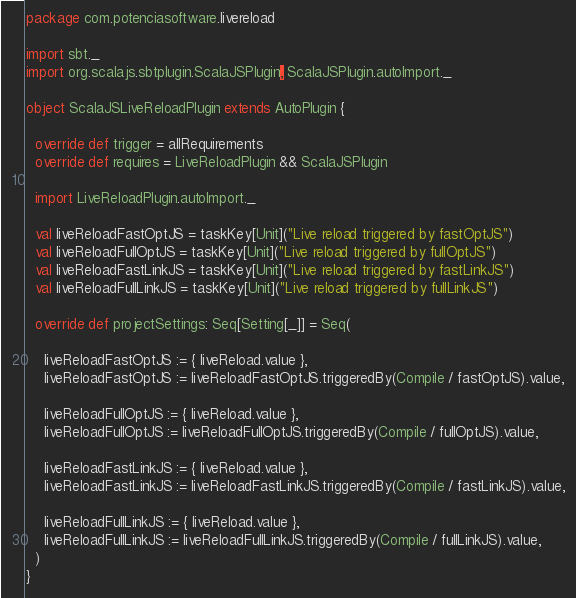<code> <loc_0><loc_0><loc_500><loc_500><_Scala_>package com.potenciasoftware.livereload

import sbt._
import org.scalajs.sbtplugin.ScalaJSPlugin, ScalaJSPlugin.autoImport._

object ScalaJSLiveReloadPlugin extends AutoPlugin {

  override def trigger = allRequirements
  override def requires = LiveReloadPlugin && ScalaJSPlugin

  import LiveReloadPlugin.autoImport._

  val liveReloadFastOptJS = taskKey[Unit]("Live reload triggered by fastOptJS")
  val liveReloadFullOptJS = taskKey[Unit]("Live reload triggered by fullOptJS")
  val liveReloadFastLinkJS = taskKey[Unit]("Live reload triggered by fastLinkJS")
  val liveReloadFullLinkJS = taskKey[Unit]("Live reload triggered by fullLinkJS")

  override def projectSettings: Seq[Setting[_]] = Seq(

    liveReloadFastOptJS := { liveReload.value },
    liveReloadFastOptJS := liveReloadFastOptJS.triggeredBy(Compile / fastOptJS).value,

    liveReloadFullOptJS := { liveReload.value },
    liveReloadFullOptJS := liveReloadFullOptJS.triggeredBy(Compile / fullOptJS).value,

    liveReloadFastLinkJS := { liveReload.value },
    liveReloadFastLinkJS := liveReloadFastLinkJS.triggeredBy(Compile / fastLinkJS).value,

    liveReloadFullLinkJS := { liveReload.value },
    liveReloadFullLinkJS := liveReloadFullLinkJS.triggeredBy(Compile / fullLinkJS).value,
  )
}
</code> 